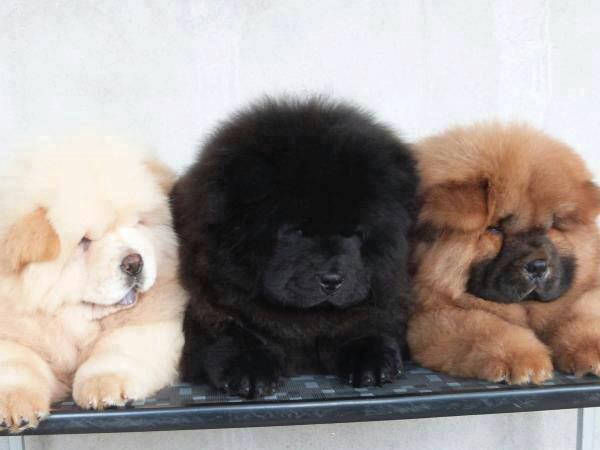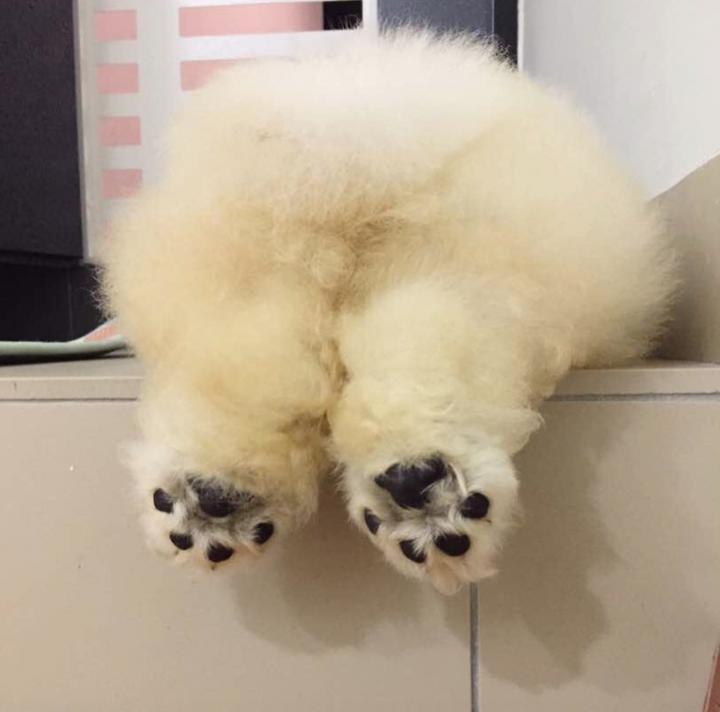The first image is the image on the left, the second image is the image on the right. For the images shown, is this caption "There are no more than two dogs in the image on the left." true? Answer yes or no. No. The first image is the image on the left, the second image is the image on the right. Assess this claim about the two images: "There are three animals". Correct or not? Answer yes or no. No. 